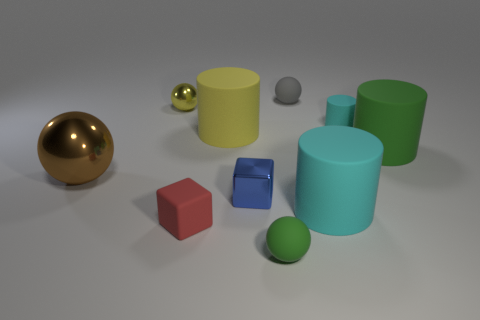What is the shape of the large object that is the same color as the small cylinder?
Give a very brief answer. Cylinder. Is the number of tiny red blocks that are behind the big cyan rubber thing the same as the number of tiny metallic blocks that are in front of the shiny block?
Offer a terse response. Yes. There is a green rubber object to the left of the green matte cylinder; what shape is it?
Provide a short and direct response. Sphere. There is a shiny object that is the same size as the green cylinder; what is its shape?
Your answer should be compact. Sphere. What color is the large matte cylinder that is behind the large matte cylinder to the right of the cyan object behind the big brown thing?
Offer a very short reply. Yellow. Is the shape of the small red thing the same as the blue thing?
Provide a short and direct response. Yes. Is the number of cyan matte cylinders that are behind the brown thing the same as the number of big gray cubes?
Your response must be concise. No. What number of other objects are there of the same material as the red cube?
Provide a short and direct response. 6. Do the green rubber thing behind the big metal object and the metal sphere in front of the small cylinder have the same size?
Give a very brief answer. Yes. What number of objects are big objects that are on the right side of the red thing or metallic spheres on the left side of the tiny yellow ball?
Provide a succinct answer. 4. 